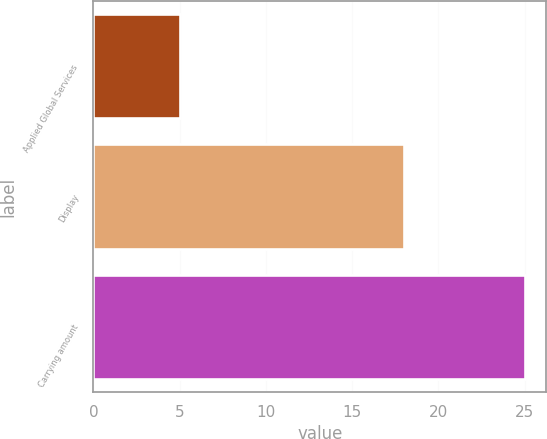<chart> <loc_0><loc_0><loc_500><loc_500><bar_chart><fcel>Applied Global Services<fcel>Display<fcel>Carrying amount<nl><fcel>5<fcel>18<fcel>25<nl></chart> 